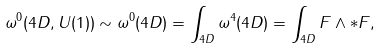<formula> <loc_0><loc_0><loc_500><loc_500>\omega ^ { 0 } ( 4 D , U ( 1 ) ) \sim \omega ^ { 0 } ( 4 D ) = \int _ { 4 D } \omega ^ { 4 } ( 4 D ) = \int _ { 4 D } F \wedge * F ,</formula> 